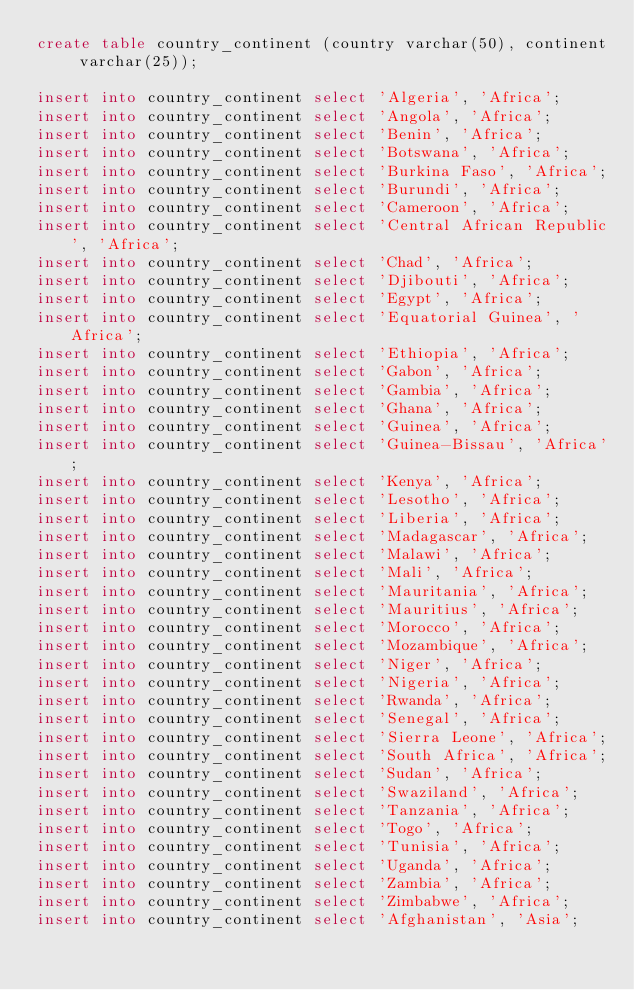<code> <loc_0><loc_0><loc_500><loc_500><_SQL_>create table country_continent (country varchar(50), continent varchar(25));

insert into country_continent select 'Algeria', 'Africa';
insert into country_continent select 'Angola', 'Africa';
insert into country_continent select 'Benin', 'Africa';
insert into country_continent select 'Botswana', 'Africa';
insert into country_continent select 'Burkina Faso', 'Africa';
insert into country_continent select 'Burundi', 'Africa';
insert into country_continent select 'Cameroon', 'Africa';
insert into country_continent select 'Central African Republic', 'Africa';
insert into country_continent select 'Chad', 'Africa';
insert into country_continent select 'Djibouti', 'Africa';
insert into country_continent select 'Egypt', 'Africa';
insert into country_continent select 'Equatorial Guinea', 'Africa';
insert into country_continent select 'Ethiopia', 'Africa';
insert into country_continent select 'Gabon', 'Africa';
insert into country_continent select 'Gambia', 'Africa';
insert into country_continent select 'Ghana', 'Africa';
insert into country_continent select 'Guinea', 'Africa';
insert into country_continent select 'Guinea-Bissau', 'Africa';
insert into country_continent select 'Kenya', 'Africa';
insert into country_continent select 'Lesotho', 'Africa';
insert into country_continent select 'Liberia', 'Africa';
insert into country_continent select 'Madagascar', 'Africa';
insert into country_continent select 'Malawi', 'Africa';
insert into country_continent select 'Mali', 'Africa';
insert into country_continent select 'Mauritania', 'Africa';
insert into country_continent select 'Mauritius', 'Africa';
insert into country_continent select 'Morocco', 'Africa';
insert into country_continent select 'Mozambique', 'Africa';
insert into country_continent select 'Niger', 'Africa';
insert into country_continent select 'Nigeria', 'Africa';
insert into country_continent select 'Rwanda', 'Africa';
insert into country_continent select 'Senegal', 'Africa';
insert into country_continent select 'Sierra Leone', 'Africa';
insert into country_continent select 'South Africa', 'Africa';
insert into country_continent select 'Sudan', 'Africa';
insert into country_continent select 'Swaziland', 'Africa';
insert into country_continent select 'Tanzania', 'Africa';
insert into country_continent select 'Togo', 'Africa';
insert into country_continent select 'Tunisia', 'Africa';
insert into country_continent select 'Uganda', 'Africa';
insert into country_continent select 'Zambia', 'Africa';
insert into country_continent select 'Zimbabwe', 'Africa';
insert into country_continent select 'Afghanistan', 'Asia';</code> 